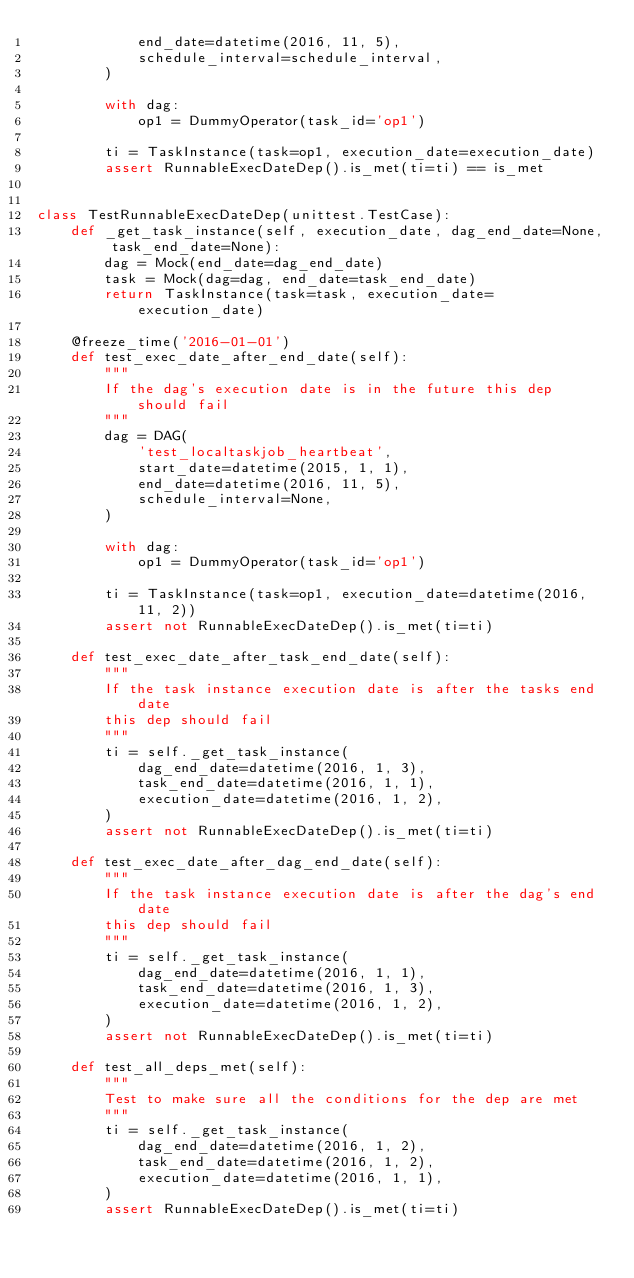Convert code to text. <code><loc_0><loc_0><loc_500><loc_500><_Python_>            end_date=datetime(2016, 11, 5),
            schedule_interval=schedule_interval,
        )

        with dag:
            op1 = DummyOperator(task_id='op1')

        ti = TaskInstance(task=op1, execution_date=execution_date)
        assert RunnableExecDateDep().is_met(ti=ti) == is_met


class TestRunnableExecDateDep(unittest.TestCase):
    def _get_task_instance(self, execution_date, dag_end_date=None, task_end_date=None):
        dag = Mock(end_date=dag_end_date)
        task = Mock(dag=dag, end_date=task_end_date)
        return TaskInstance(task=task, execution_date=execution_date)

    @freeze_time('2016-01-01')
    def test_exec_date_after_end_date(self):
        """
        If the dag's execution date is in the future this dep should fail
        """
        dag = DAG(
            'test_localtaskjob_heartbeat',
            start_date=datetime(2015, 1, 1),
            end_date=datetime(2016, 11, 5),
            schedule_interval=None,
        )

        with dag:
            op1 = DummyOperator(task_id='op1')

        ti = TaskInstance(task=op1, execution_date=datetime(2016, 11, 2))
        assert not RunnableExecDateDep().is_met(ti=ti)

    def test_exec_date_after_task_end_date(self):
        """
        If the task instance execution date is after the tasks end date
        this dep should fail
        """
        ti = self._get_task_instance(
            dag_end_date=datetime(2016, 1, 3),
            task_end_date=datetime(2016, 1, 1),
            execution_date=datetime(2016, 1, 2),
        )
        assert not RunnableExecDateDep().is_met(ti=ti)

    def test_exec_date_after_dag_end_date(self):
        """
        If the task instance execution date is after the dag's end date
        this dep should fail
        """
        ti = self._get_task_instance(
            dag_end_date=datetime(2016, 1, 1),
            task_end_date=datetime(2016, 1, 3),
            execution_date=datetime(2016, 1, 2),
        )
        assert not RunnableExecDateDep().is_met(ti=ti)

    def test_all_deps_met(self):
        """
        Test to make sure all the conditions for the dep are met
        """
        ti = self._get_task_instance(
            dag_end_date=datetime(2016, 1, 2),
            task_end_date=datetime(2016, 1, 2),
            execution_date=datetime(2016, 1, 1),
        )
        assert RunnableExecDateDep().is_met(ti=ti)
</code> 